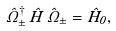<formula> <loc_0><loc_0><loc_500><loc_500>\hat { \Omega } _ { \pm } ^ { \dagger } \, \hat { H } \, \hat { \Omega } _ { \pm } = \hat { H } _ { 0 } ,</formula> 